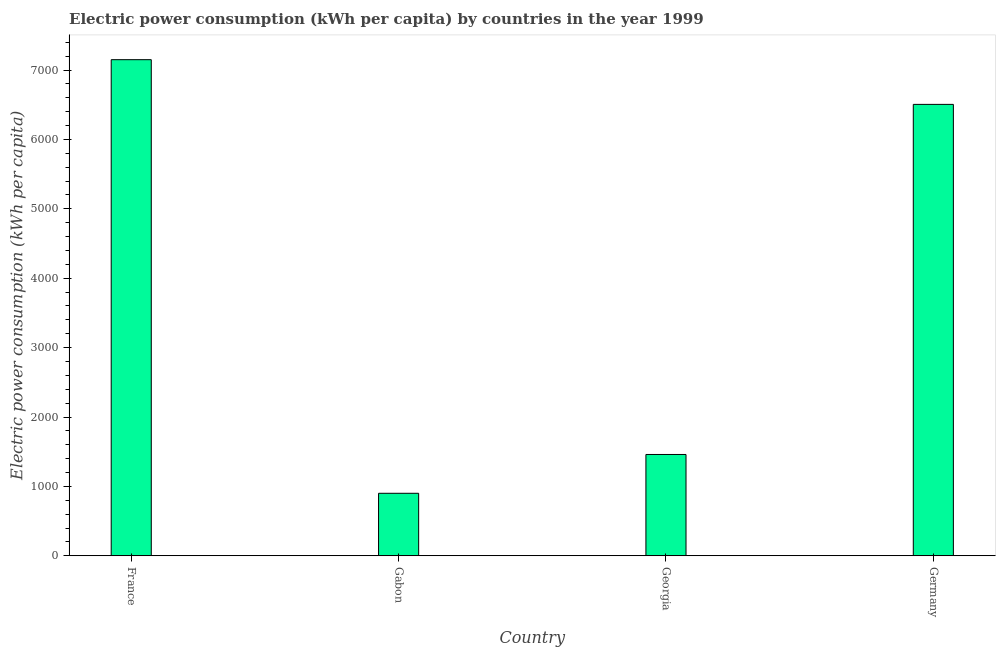Does the graph contain grids?
Provide a short and direct response. No. What is the title of the graph?
Your answer should be compact. Electric power consumption (kWh per capita) by countries in the year 1999. What is the label or title of the Y-axis?
Give a very brief answer. Electric power consumption (kWh per capita). What is the electric power consumption in Gabon?
Make the answer very short. 900.69. Across all countries, what is the maximum electric power consumption?
Ensure brevity in your answer.  7149.3. Across all countries, what is the minimum electric power consumption?
Keep it short and to the point. 900.69. In which country was the electric power consumption maximum?
Give a very brief answer. France. In which country was the electric power consumption minimum?
Your answer should be very brief. Gabon. What is the sum of the electric power consumption?
Your response must be concise. 1.60e+04. What is the difference between the electric power consumption in Georgia and Germany?
Give a very brief answer. -5045.05. What is the average electric power consumption per country?
Offer a very short reply. 4003.8. What is the median electric power consumption?
Offer a terse response. 3982.61. In how many countries, is the electric power consumption greater than 4200 kWh per capita?
Your answer should be very brief. 2. What is the ratio of the electric power consumption in Gabon to that in Georgia?
Provide a short and direct response. 0.62. What is the difference between the highest and the second highest electric power consumption?
Make the answer very short. 644.16. What is the difference between the highest and the lowest electric power consumption?
Your response must be concise. 6248.61. How many bars are there?
Your response must be concise. 4. What is the difference between two consecutive major ticks on the Y-axis?
Make the answer very short. 1000. What is the Electric power consumption (kWh per capita) in France?
Ensure brevity in your answer.  7149.3. What is the Electric power consumption (kWh per capita) of Gabon?
Offer a very short reply. 900.69. What is the Electric power consumption (kWh per capita) of Georgia?
Give a very brief answer. 1460.08. What is the Electric power consumption (kWh per capita) in Germany?
Your answer should be compact. 6505.13. What is the difference between the Electric power consumption (kWh per capita) in France and Gabon?
Offer a terse response. 6248.61. What is the difference between the Electric power consumption (kWh per capita) in France and Georgia?
Ensure brevity in your answer.  5689.22. What is the difference between the Electric power consumption (kWh per capita) in France and Germany?
Make the answer very short. 644.16. What is the difference between the Electric power consumption (kWh per capita) in Gabon and Georgia?
Provide a succinct answer. -559.39. What is the difference between the Electric power consumption (kWh per capita) in Gabon and Germany?
Your response must be concise. -5604.44. What is the difference between the Electric power consumption (kWh per capita) in Georgia and Germany?
Provide a succinct answer. -5045.05. What is the ratio of the Electric power consumption (kWh per capita) in France to that in Gabon?
Give a very brief answer. 7.94. What is the ratio of the Electric power consumption (kWh per capita) in France to that in Georgia?
Your answer should be compact. 4.9. What is the ratio of the Electric power consumption (kWh per capita) in France to that in Germany?
Offer a very short reply. 1.1. What is the ratio of the Electric power consumption (kWh per capita) in Gabon to that in Georgia?
Your answer should be compact. 0.62. What is the ratio of the Electric power consumption (kWh per capita) in Gabon to that in Germany?
Offer a very short reply. 0.14. What is the ratio of the Electric power consumption (kWh per capita) in Georgia to that in Germany?
Provide a succinct answer. 0.22. 